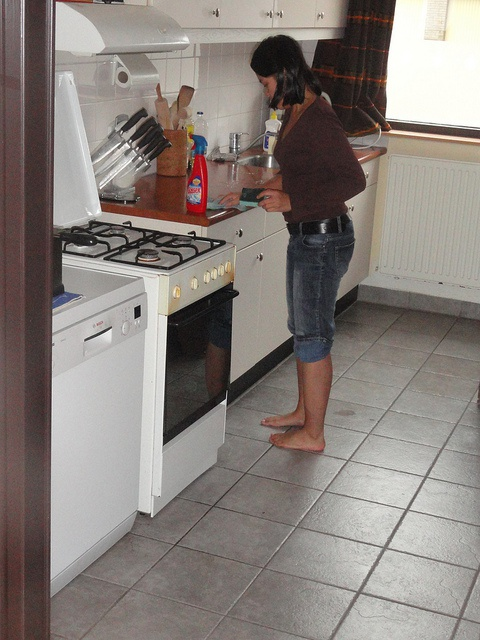Describe the objects in this image and their specific colors. I can see oven in gray, darkgray, black, and lightgray tones, people in gray, black, brown, and maroon tones, bottle in gray, brown, blue, and navy tones, knife in gray, black, lightgray, and darkgray tones, and bottle in gray, darkgray, and tan tones in this image. 